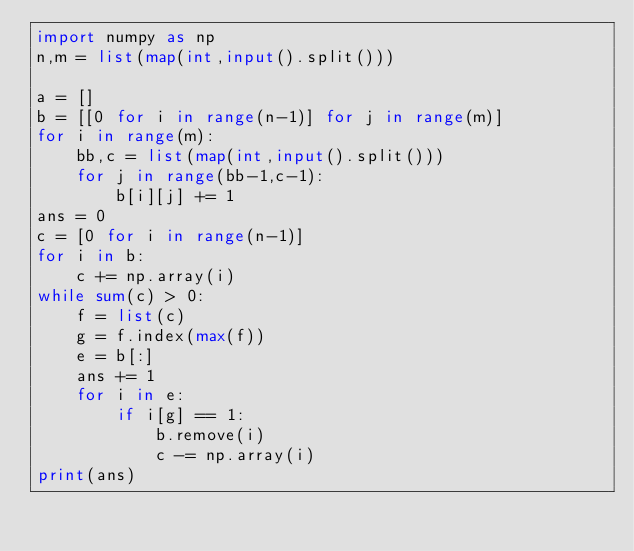Convert code to text. <code><loc_0><loc_0><loc_500><loc_500><_Python_>import numpy as np
n,m = list(map(int,input().split()))

a = []
b = [[0 for i in range(n-1)] for j in range(m)]
for i in range(m):
    bb,c = list(map(int,input().split()))
    for j in range(bb-1,c-1):
        b[i][j] += 1
ans = 0
c = [0 for i in range(n-1)]
for i in b:
    c += np.array(i)
while sum(c) > 0:
    f = list(c)
    g = f.index(max(f))
    e = b[:]
    ans += 1
    for i in e:
        if i[g] == 1:
            b.remove(i)
            c -= np.array(i)
print(ans)</code> 